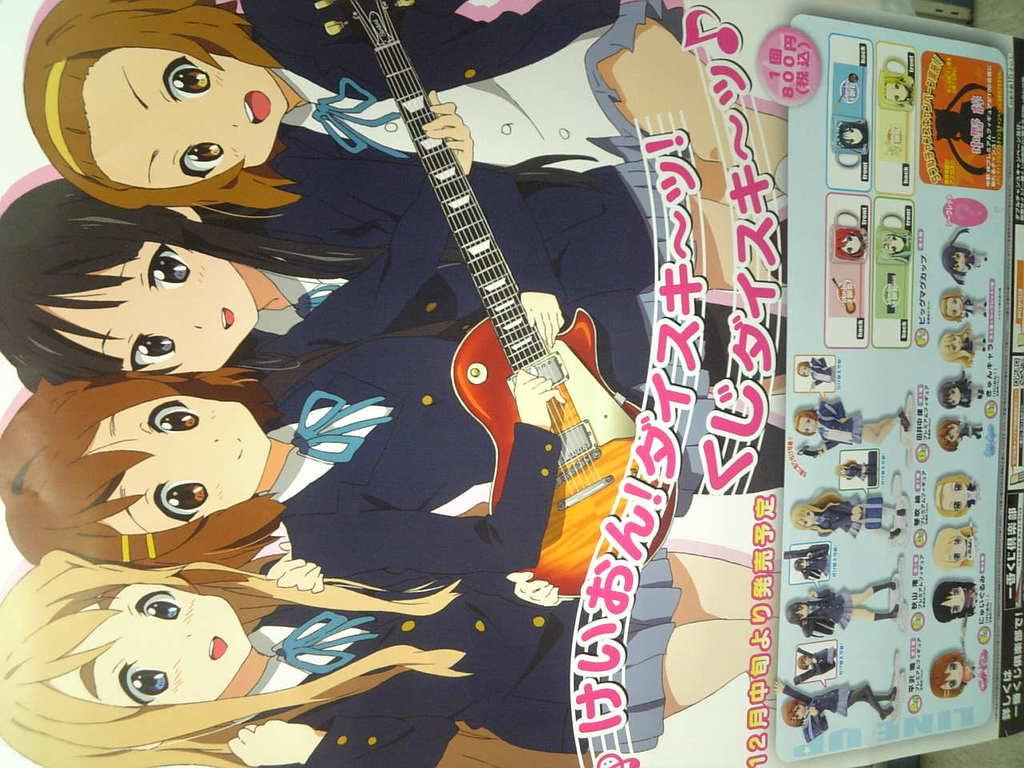What is featured on the poster in the image? The poster contains cartoons and a guitar. What type of images can be seen on the poster? The images on the poster are cartoons. What object is depicted alongside the cartoons on the poster? There is a guitar depicted on the poster. What type of grain is being harvested in the image? There is no grain present in the image; it features a poster with cartoons and a guitar. What is the income of the person depicted in the image? There is no person depicted in the image, as it features a poster with cartoons and a guitar. 